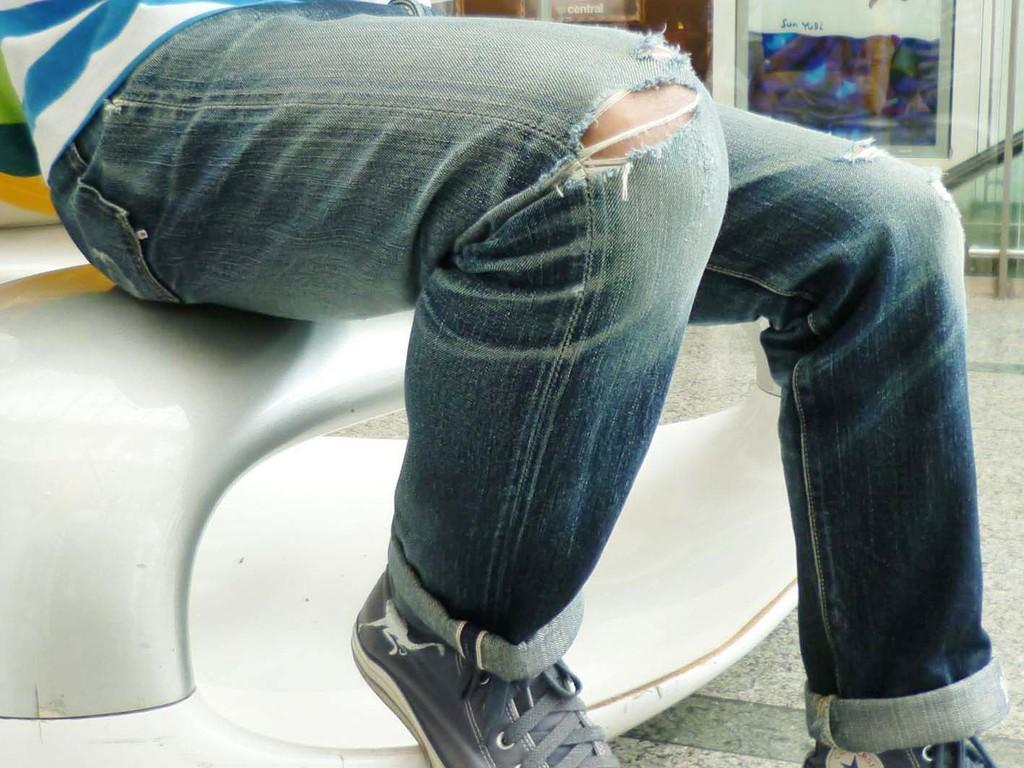What part of the man is visible in the image? Only the legs of a man are visible in the image. What type of clothing is the man wearing on his legs? The man is wearing torn jeans. What type of footwear is the man wearing? The man is wearing shoes. What can be seen behind the man in the image? There are showrooms visible behind the man. What type of string is the man holding in the image? There is no string visible in the image; only the man's legs are visible. How does the man's appearance compare to that of a famous celebrity in the image? The image does not include any comparison to a famous celebrity, as only the man's legs are visible. 